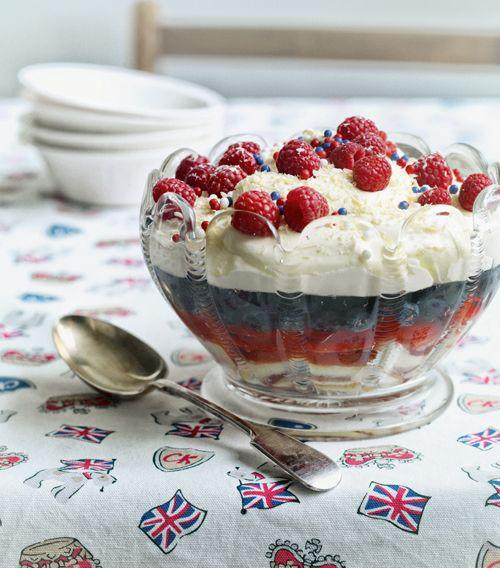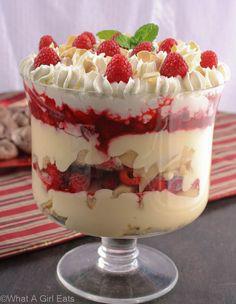The first image is the image on the left, the second image is the image on the right. Considering the images on both sides, is "The left image shows one dessert with one spoon." valid? Answer yes or no. Yes. 